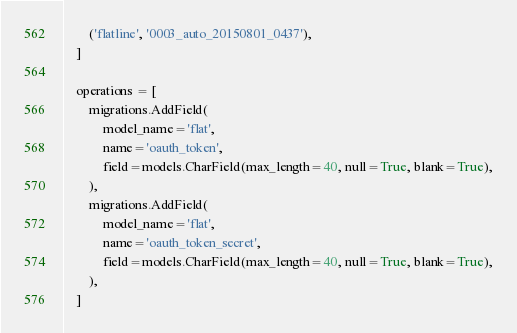<code> <loc_0><loc_0><loc_500><loc_500><_Python_>        ('flatline', '0003_auto_20150801_0437'),
    ]

    operations = [
        migrations.AddField(
            model_name='flat',
            name='oauth_token',
            field=models.CharField(max_length=40, null=True, blank=True),
        ),
        migrations.AddField(
            model_name='flat',
            name='oauth_token_secret',
            field=models.CharField(max_length=40, null=True, blank=True),
        ),
    ]
</code> 